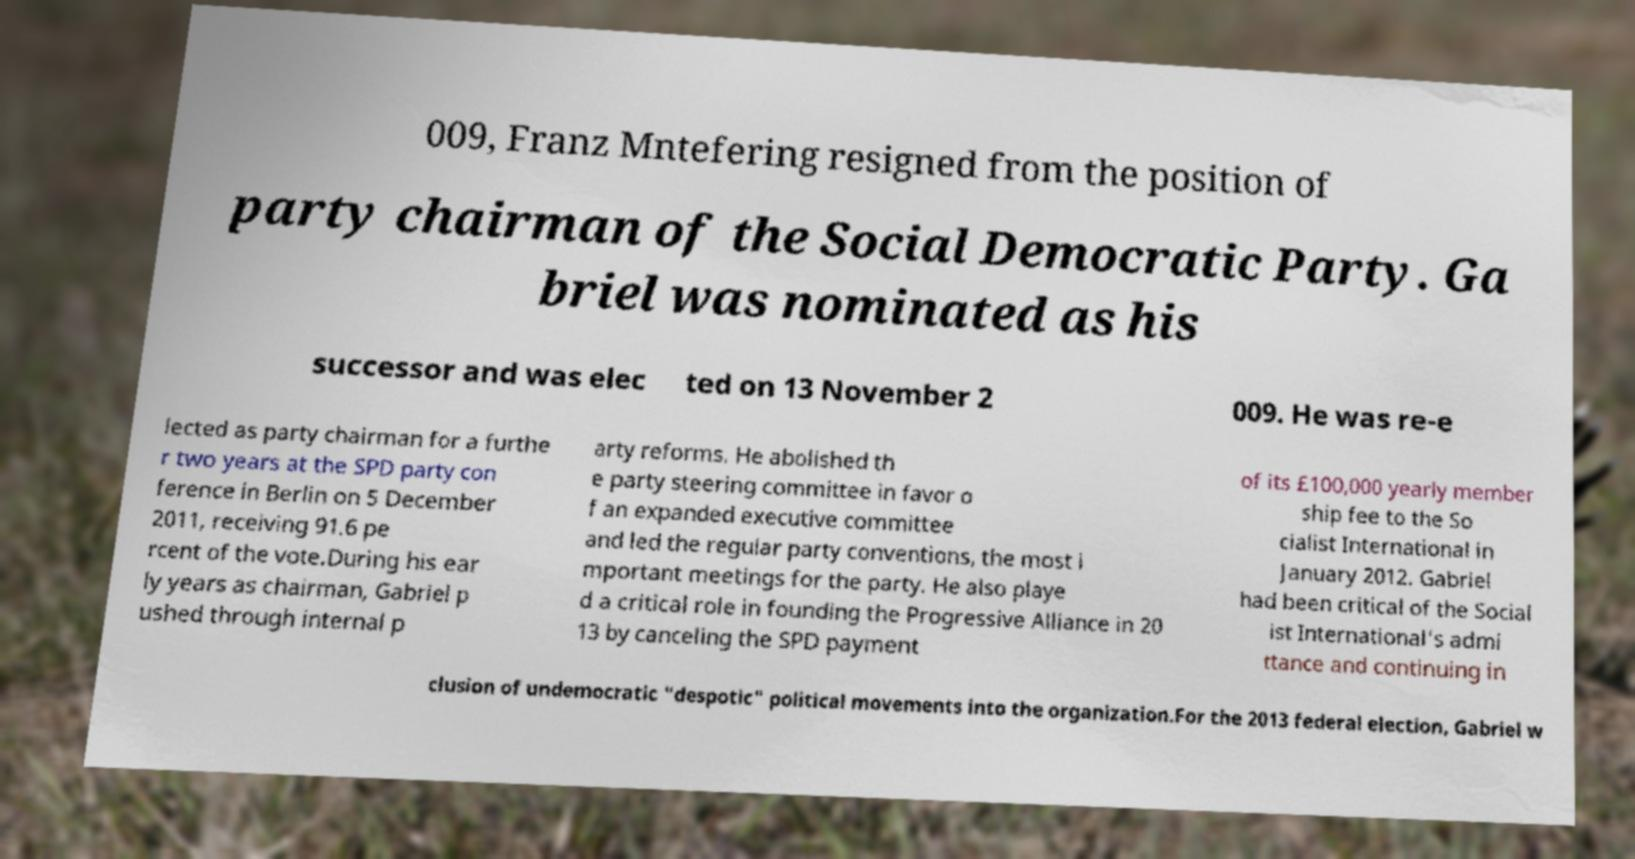What messages or text are displayed in this image? I need them in a readable, typed format. 009, Franz Mntefering resigned from the position of party chairman of the Social Democratic Party. Ga briel was nominated as his successor and was elec ted on 13 November 2 009. He was re-e lected as party chairman for a furthe r two years at the SPD party con ference in Berlin on 5 December 2011, receiving 91.6 pe rcent of the vote.During his ear ly years as chairman, Gabriel p ushed through internal p arty reforms. He abolished th e party steering committee in favor o f an expanded executive committee and led the regular party conventions, the most i mportant meetings for the party. He also playe d a critical role in founding the Progressive Alliance in 20 13 by canceling the SPD payment of its £100,000 yearly member ship fee to the So cialist International in January 2012. Gabriel had been critical of the Social ist International's admi ttance and continuing in clusion of undemocratic "despotic" political movements into the organization.For the 2013 federal election, Gabriel w 